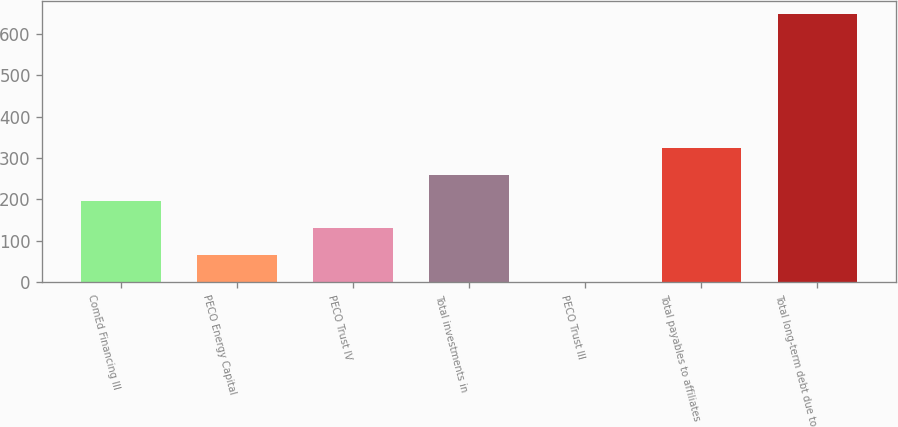Convert chart to OTSL. <chart><loc_0><loc_0><loc_500><loc_500><bar_chart><fcel>ComEd Financing III<fcel>PECO Energy Capital<fcel>PECO Trust IV<fcel>Total investments in<fcel>PECO Trust III<fcel>Total payables to affiliates<fcel>Total long-term debt due to<nl><fcel>195.1<fcel>65.7<fcel>130.4<fcel>259.8<fcel>1<fcel>324.5<fcel>648<nl></chart> 